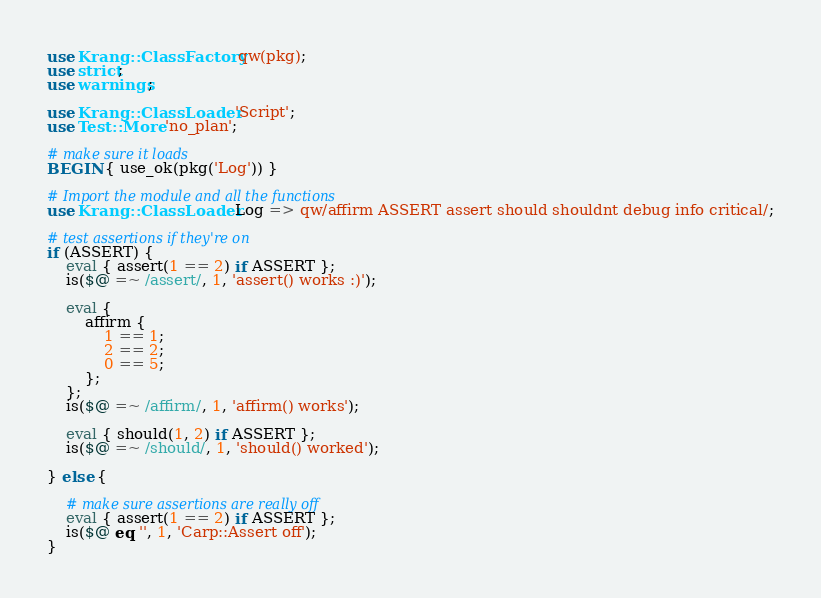Convert code to text. <code><loc_0><loc_0><loc_500><loc_500><_Perl_>use Krang::ClassFactory qw(pkg);
use strict;
use warnings;

use Krang::ClassLoader 'Script';
use Test::More 'no_plan';

# make sure it loads
BEGIN { use_ok(pkg('Log')) }

# Import the module and all the functions
use Krang::ClassLoader Log => qw/affirm ASSERT assert should shouldnt debug info critical/;

# test assertions if they're on
if (ASSERT) {
    eval { assert(1 == 2) if ASSERT };
    is($@ =~ /assert/, 1, 'assert() works :)');

    eval {
        affirm {
            1 == 1;
            2 == 2;
            0 == 5;
        };
    };
    is($@ =~ /affirm/, 1, 'affirm() works');

    eval { should(1, 2) if ASSERT };
    is($@ =~ /should/, 1, 'should() worked');

} else {

    # make sure assertions are really off
    eval { assert(1 == 2) if ASSERT };
    is($@ eq '', 1, 'Carp::Assert off');
}
</code> 